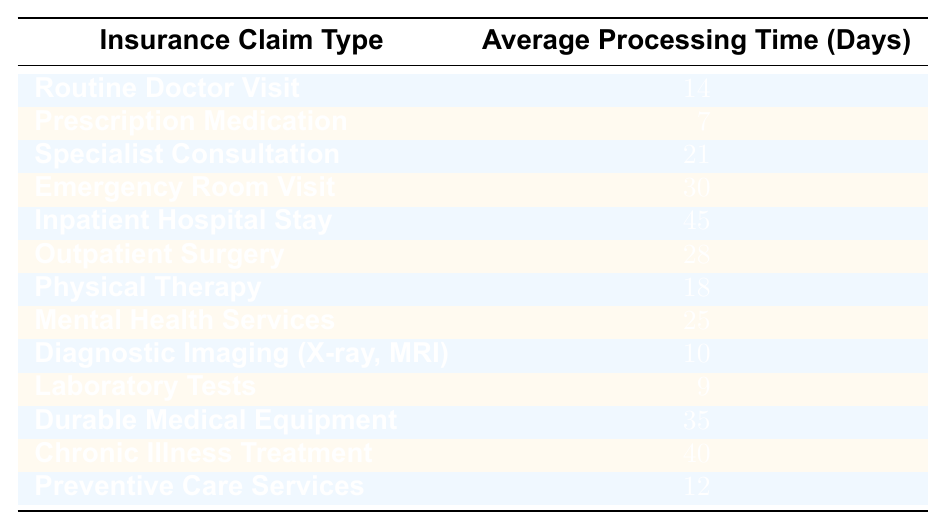What is the average processing time for a Prescription Medication claim? The table shows that the average processing time for Prescription Medication is listed as 7 days.
Answer: 7 days Which type of insurance claim has the longest average processing time? By reviewing the table, the claim type with the longest average processing time is Inpatient Hospital Stay, which takes 45 days.
Answer: Inpatient Hospital Stay How many days does it take on average for an Emergency Room Visit claim to be processed? The average processing time for an Emergency Room Visit is specified in the table as 30 days.
Answer: 30 days What is the average processing time for Physical Therapy and Mental Health Services combined? The average processing time for Physical Therapy is 18 days and for Mental Health Services is 25 days. Adding these gives 18 + 25 = 43 days. To find the average, divide by 2 (43/2 = 21.5 days).
Answer: 21.5 days Is the average processing time for Outpatient Surgery less than that for Specialist Consultation? The average processing time for Outpatient Surgery is 28 days, while Specialist Consultation is 21 days. Since 28 is greater than 21, the statement is false.
Answer: No What is the difference in average processing time between Durable Medical Equipment and Chronic Illness Treatment? The average processing time for Durable Medical Equipment is 35 days, and for Chronic Illness Treatment, it is 40 days. The difference is 40 - 35 = 5 days.
Answer: 5 days If you sum the average processing times of all claims listed, what is the total? Adding all the average processing times (14 + 7 + 21 + 30 + 45 + 28 + 18 + 25 + 10 + 9 + 35 + 40 + 12) results in  14 + 7 + 21 + 30 + 45 + 28 + 18 + 25 + 10 + 9 + 35 + 40 + 12 =  324 days in total.
Answer: 324 days How many claims have an average processing time greater than 30 days? The claims that have average processing times greater than 30 days are Inpatient Hospital Stay (45 days), Emergency Room Visit (30 days), and Durable Medical Equipment (35 days), totaling three claims.
Answer: 3 claims What is the average processing time for the claims related to mental health services? The average processing time for Mental Health Services in the table is 25 days, while considering Physical Therapy (18 days) and Specialist Consultation (21 days) as mental health-related services, the average would be (25 + 18 + 21) / 3 = 21.33 days.
Answer: 21.33 days Does the average processing time for Routine Doctor Visits exceed that for Preventive Care Services? The average processing time for Routine Doctor Visits is 14 days, and for Preventive Care Services, it is 12 days. Since 14 is greater than 12, the statement is true.
Answer: Yes 